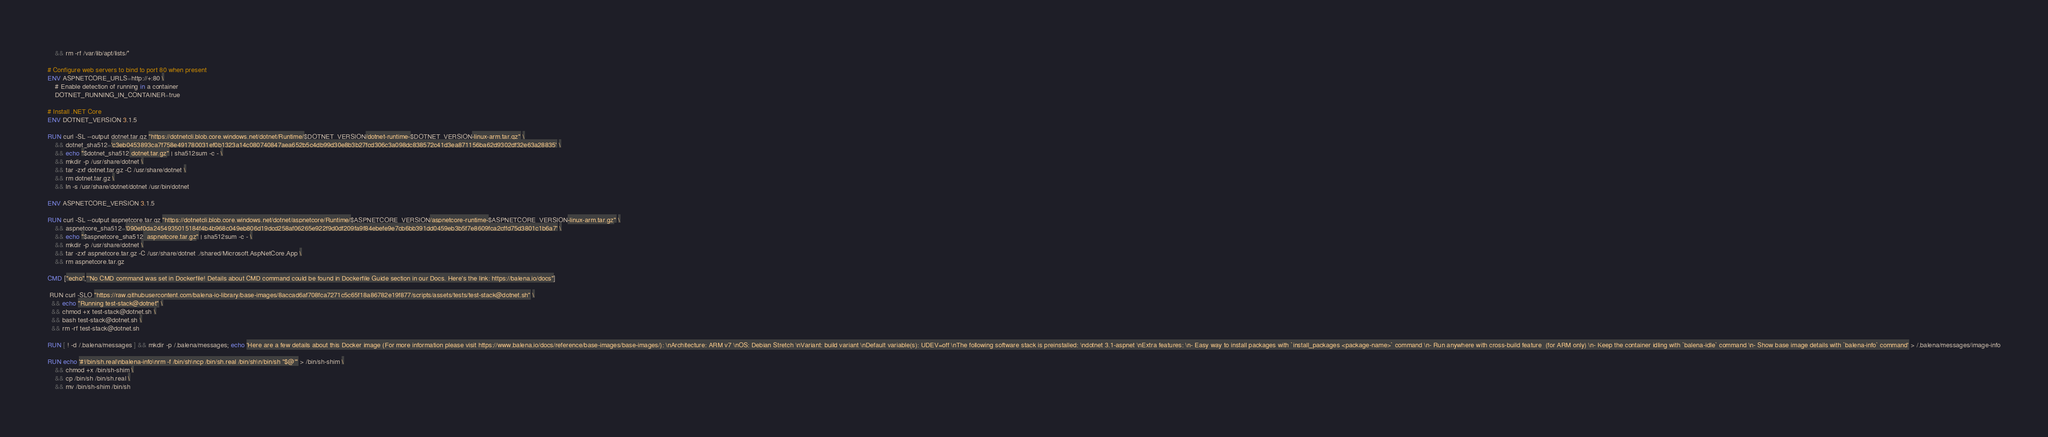Convert code to text. <code><loc_0><loc_0><loc_500><loc_500><_Dockerfile_>    && rm -rf /var/lib/apt/lists/*

# Configure web servers to bind to port 80 when present
ENV ASPNETCORE_URLS=http://+:80 \
    # Enable detection of running in a container
    DOTNET_RUNNING_IN_CONTAINER=true

# Install .NET Core
ENV DOTNET_VERSION 3.1.5

RUN curl -SL --output dotnet.tar.gz "https://dotnetcli.blob.core.windows.net/dotnet/Runtime/$DOTNET_VERSION/dotnet-runtime-$DOTNET_VERSION-linux-arm.tar.gz" \
    && dotnet_sha512='c3eb0453893ca7f758e491780031ef0b1323a14c080740847aea652b5c4db99d30e8b3b27fcd306c3a098dc838572c41d3ea871156ba62d9302df32e63a28835' \
    && echo "$dotnet_sha512 dotnet.tar.gz" | sha512sum -c - \
    && mkdir -p /usr/share/dotnet \
    && tar -zxf dotnet.tar.gz -C /usr/share/dotnet \
    && rm dotnet.tar.gz \
    && ln -s /usr/share/dotnet/dotnet /usr/bin/dotnet

ENV ASPNETCORE_VERSION 3.1.5

RUN curl -SL --output aspnetcore.tar.gz "https://dotnetcli.blob.core.windows.net/dotnet/aspnetcore/Runtime/$ASPNETCORE_VERSION/aspnetcore-runtime-$ASPNETCORE_VERSION-linux-arm.tar.gz" \
    && aspnetcore_sha512='090ef0da2454935015184f4b4b968c049eb806d19dcd258af06265e922f9d0df209fa9f84ebefe9e7cb6bb391dd0459eb3b5f7e8609fca2cffd75d3801c1b6a7' \
    && echo "$aspnetcore_sha512  aspnetcore.tar.gz" | sha512sum -c - \
    && mkdir -p /usr/share/dotnet \
    && tar -zxf aspnetcore.tar.gz -C /usr/share/dotnet ./shared/Microsoft.AspNetCore.App \
    && rm aspnetcore.tar.gz

CMD ["echo","'No CMD command was set in Dockerfile! Details about CMD command could be found in Dockerfile Guide section in our Docs. Here's the link: https://balena.io/docs"]

 RUN curl -SLO "https://raw.githubusercontent.com/balena-io-library/base-images/8accad6af708fca7271c5c65f18a86782e19f877/scripts/assets/tests/test-stack@dotnet.sh" \
  && echo "Running test-stack@dotnet" \
  && chmod +x test-stack@dotnet.sh \
  && bash test-stack@dotnet.sh \
  && rm -rf test-stack@dotnet.sh 

RUN [ ! -d /.balena/messages ] && mkdir -p /.balena/messages; echo 'Here are a few details about this Docker image (For more information please visit https://www.balena.io/docs/reference/base-images/base-images/): \nArchitecture: ARM v7 \nOS: Debian Stretch \nVariant: build variant \nDefault variable(s): UDEV=off \nThe following software stack is preinstalled: \ndotnet 3.1-aspnet \nExtra features: \n- Easy way to install packages with `install_packages <package-name>` command \n- Run anywhere with cross-build feature  (for ARM only) \n- Keep the container idling with `balena-idle` command \n- Show base image details with `balena-info` command' > /.balena/messages/image-info

RUN echo '#!/bin/sh.real\nbalena-info\nrm -f /bin/sh\ncp /bin/sh.real /bin/sh\n/bin/sh "$@"' > /bin/sh-shim \
	&& chmod +x /bin/sh-shim \
	&& cp /bin/sh /bin/sh.real \
	&& mv /bin/sh-shim /bin/sh</code> 